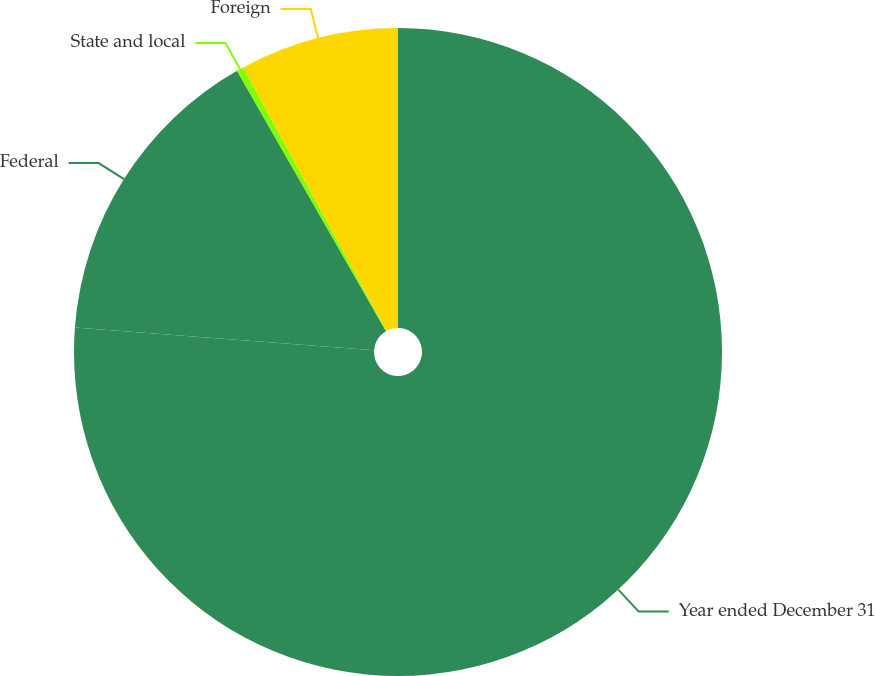Convert chart. <chart><loc_0><loc_0><loc_500><loc_500><pie_chart><fcel>Year ended December 31<fcel>Federal<fcel>State and local<fcel>Foreign<nl><fcel>76.2%<fcel>15.52%<fcel>0.35%<fcel>7.93%<nl></chart> 